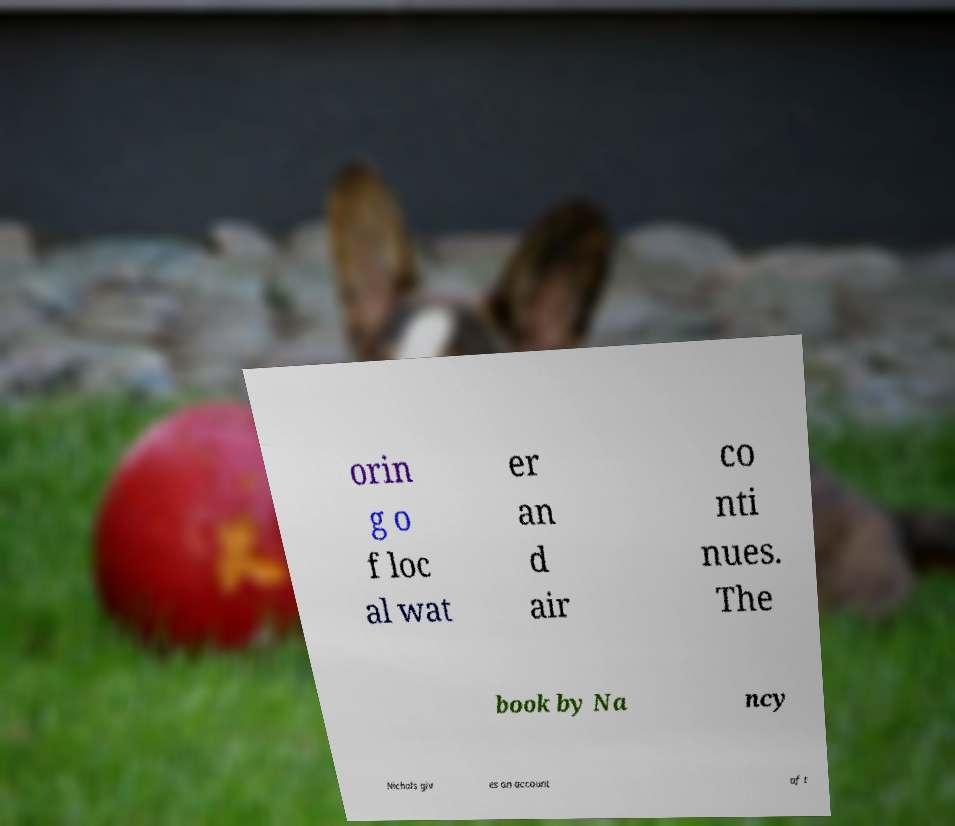Can you accurately transcribe the text from the provided image for me? orin g o f loc al wat er an d air co nti nues. The book by Na ncy Nichols giv es an account of t 